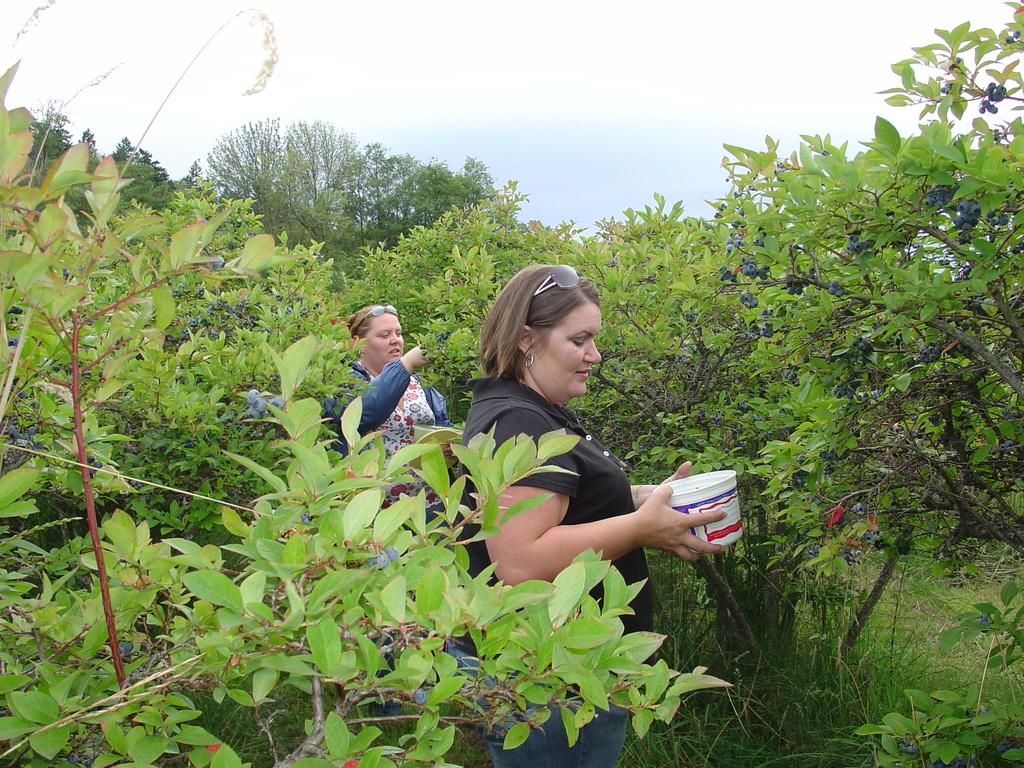How many people are in the image? There are two women in the image. What is one of the women doing in the image? One of the women is holding an object in her hands. What can be seen in the background of the image? There are trees and the sky visible in the background of the image. What type of screw can be seen in the image? There is no screw present in the image. What effect does the recess have on the women in the image? There is no recess present in the image, so it cannot have any effect on the women. 